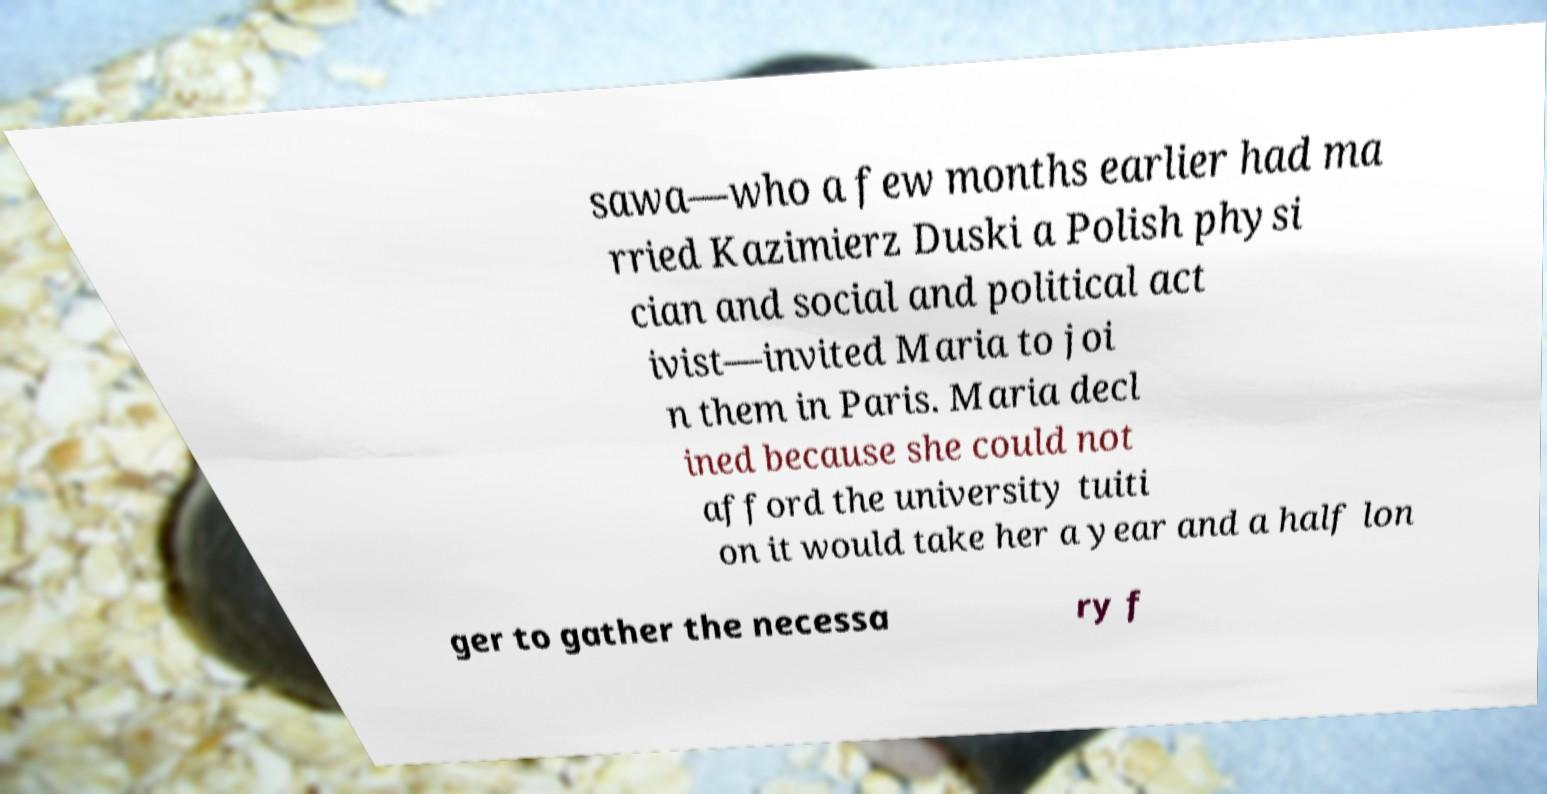Please read and relay the text visible in this image. What does it say? sawa—who a few months earlier had ma rried Kazimierz Duski a Polish physi cian and social and political act ivist—invited Maria to joi n them in Paris. Maria decl ined because she could not afford the university tuiti on it would take her a year and a half lon ger to gather the necessa ry f 